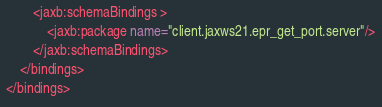<code> <loc_0><loc_0><loc_500><loc_500><_XML_>        <jaxb:schemaBindings >
            <jaxb:package name="client.jaxws21.epr_get_port.server"/>
        </jaxb:schemaBindings>
    </bindings>
</bindings>

</code> 